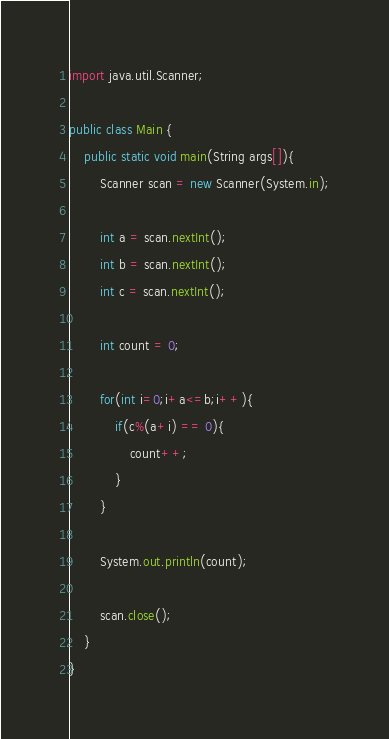Convert code to text. <code><loc_0><loc_0><loc_500><loc_500><_Java_>import java.util.Scanner;

public class Main {
	public static void main(String args[]){
		Scanner scan = new Scanner(System.in);

		int a = scan.nextInt();
		int b = scan.nextInt();
		int c = scan.nextInt();

		int count = 0;

		for(int i=0;i+a<=b;i++){
			if(c%(a+i) == 0){
				count++;
			}
		}

		System.out.println(count);

		scan.close();
	}
}</code> 